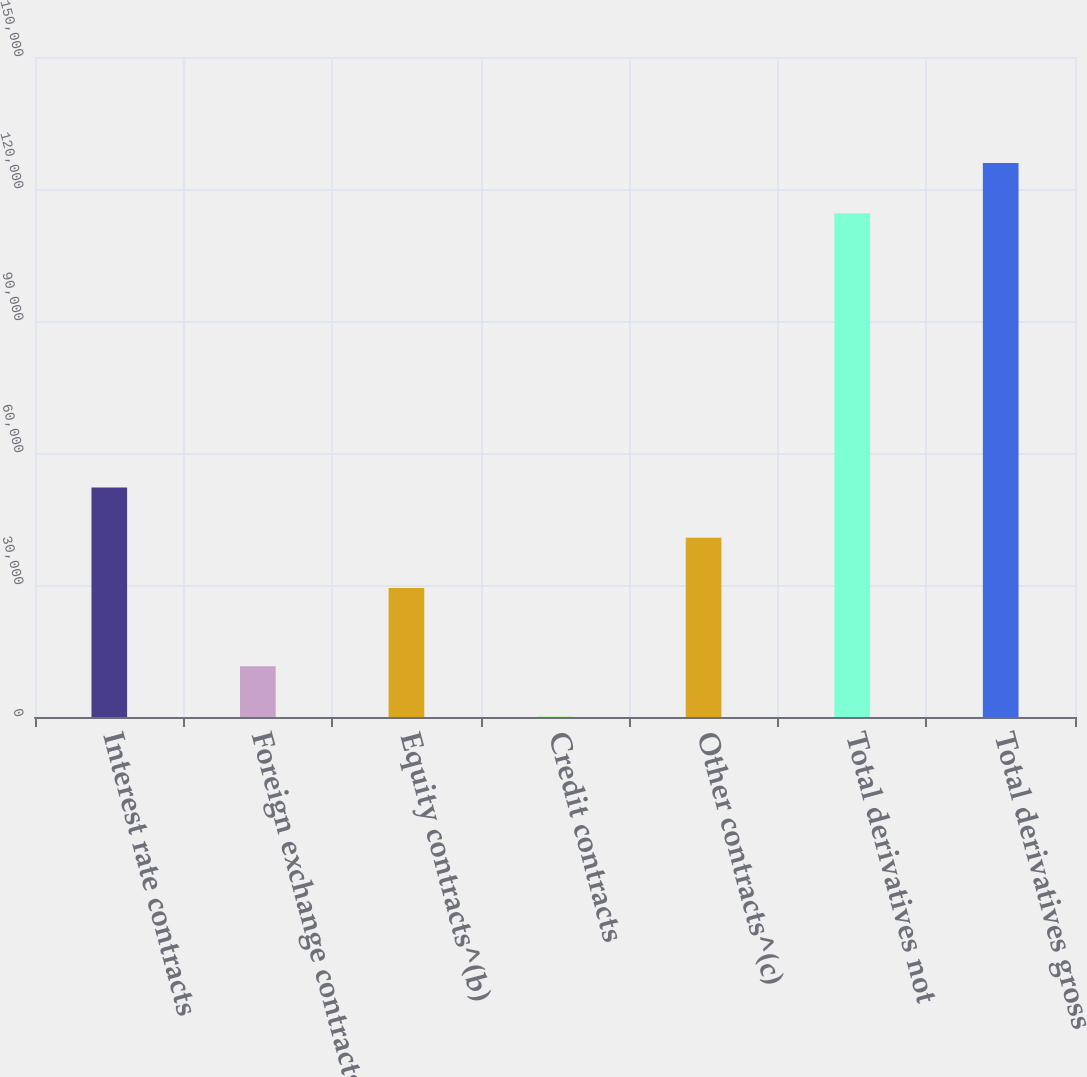<chart> <loc_0><loc_0><loc_500><loc_500><bar_chart><fcel>Interest rate contracts<fcel>Foreign exchange contracts<fcel>Equity contracts^(b)<fcel>Credit contracts<fcel>Other contracts^(c)<fcel>Total derivatives not<fcel>Total derivatives gross<nl><fcel>52180.8<fcel>11512.4<fcel>29296<fcel>70<fcel>40738.4<fcel>114494<fcel>125936<nl></chart> 